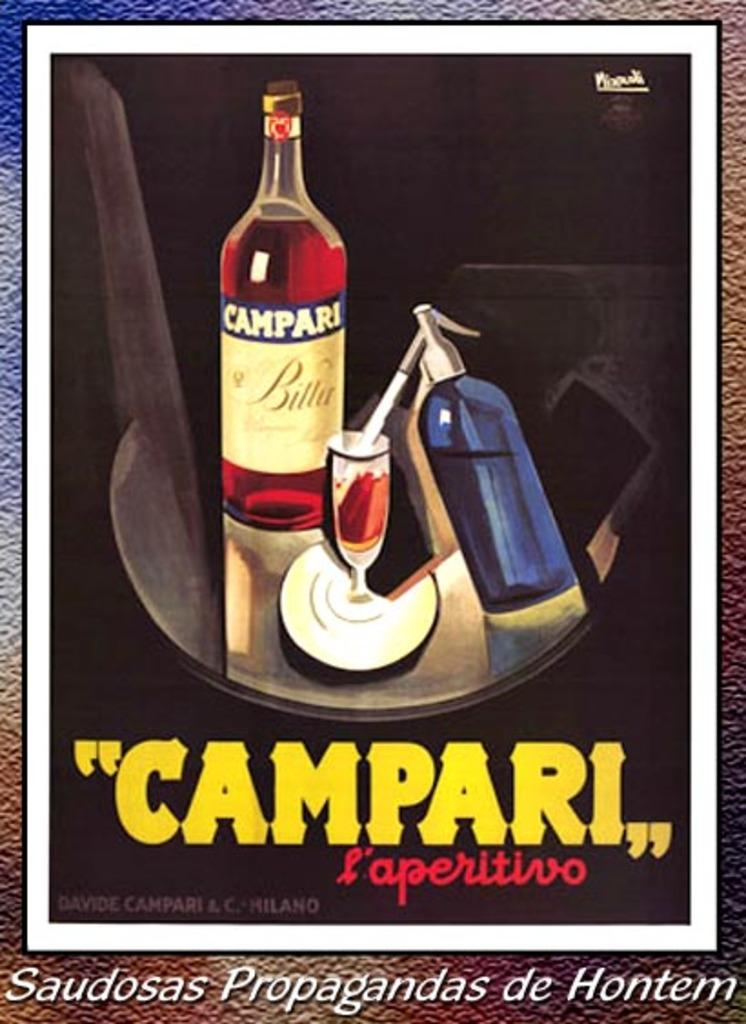What is depicted on the poster in the image? There is a poster in the image, and it features two bottles and a glass. What else can be seen on the poster? There is something written on the poster. What type of hate can be seen on the poster? There is no hate depicted on the poster; it features two bottles, a glass, and something written. What is the taste of the drink in the glass on the poster? There is no drink in the glass on the poster, so it is not possible to determine its taste. 